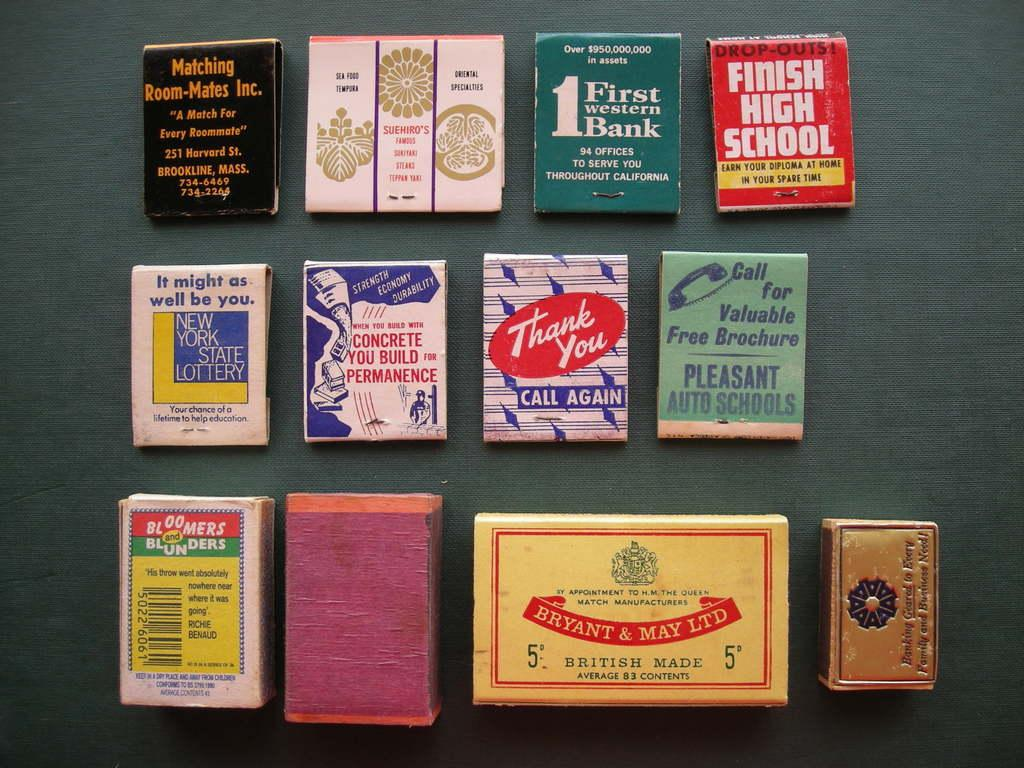<image>
Offer a succinct explanation of the picture presented. An assortment of old matchbook covers are on display, including one saying finish high school. 